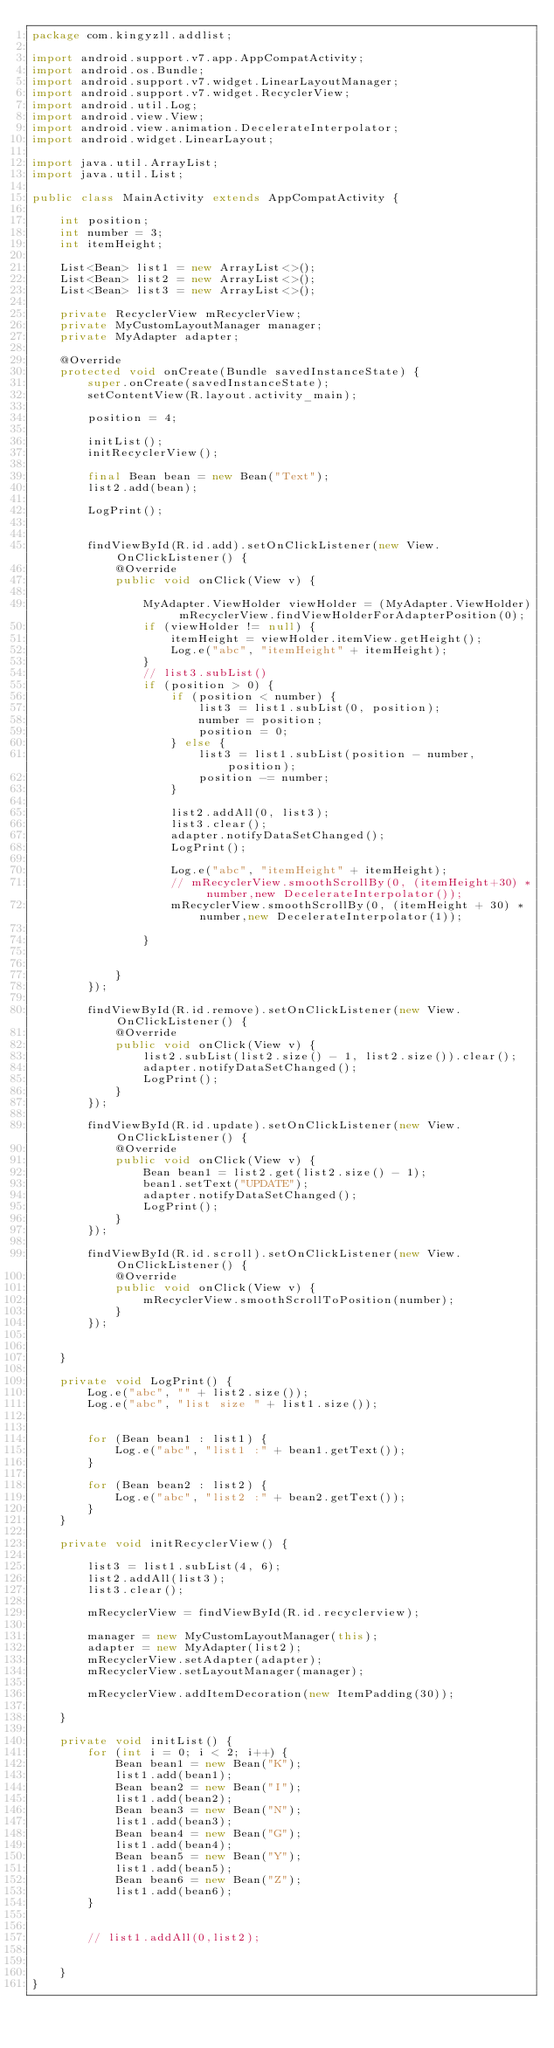<code> <loc_0><loc_0><loc_500><loc_500><_Java_>package com.kingyzll.addlist;

import android.support.v7.app.AppCompatActivity;
import android.os.Bundle;
import android.support.v7.widget.LinearLayoutManager;
import android.support.v7.widget.RecyclerView;
import android.util.Log;
import android.view.View;
import android.view.animation.DecelerateInterpolator;
import android.widget.LinearLayout;

import java.util.ArrayList;
import java.util.List;

public class MainActivity extends AppCompatActivity {

    int position;
    int number = 3;
    int itemHeight;

    List<Bean> list1 = new ArrayList<>();
    List<Bean> list2 = new ArrayList<>();
    List<Bean> list3 = new ArrayList<>();

    private RecyclerView mRecyclerView;
    private MyCustomLayoutManager manager;
    private MyAdapter adapter;

    @Override
    protected void onCreate(Bundle savedInstanceState) {
        super.onCreate(savedInstanceState);
        setContentView(R.layout.activity_main);

        position = 4;

        initList();
        initRecyclerView();

        final Bean bean = new Bean("Text");
        list2.add(bean);

        LogPrint();


        findViewById(R.id.add).setOnClickListener(new View.OnClickListener() {
            @Override
            public void onClick(View v) {

                MyAdapter.ViewHolder viewHolder = (MyAdapter.ViewHolder) mRecyclerView.findViewHolderForAdapterPosition(0);
                if (viewHolder != null) {
                    itemHeight = viewHolder.itemView.getHeight();
                    Log.e("abc", "itemHeight" + itemHeight);
                }
                // list3.subList()
                if (position > 0) {
                    if (position < number) {
                        list3 = list1.subList(0, position);
                        number = position;
                        position = 0;
                    } else {
                        list3 = list1.subList(position - number, position);
                        position -= number;
                    }

                    list2.addAll(0, list3);
                    list3.clear();
                    adapter.notifyDataSetChanged();
                    LogPrint();

                    Log.e("abc", "itemHeight" + itemHeight);
                    // mRecyclerView.smoothScrollBy(0, (itemHeight+30) * number,new DecelerateInterpolator());
                    mRecyclerView.smoothScrollBy(0, (itemHeight + 30) * number,new DecelerateInterpolator(1));

                }


            }
        });

        findViewById(R.id.remove).setOnClickListener(new View.OnClickListener() {
            @Override
            public void onClick(View v) {
                list2.subList(list2.size() - 1, list2.size()).clear();
                adapter.notifyDataSetChanged();
                LogPrint();
            }
        });

        findViewById(R.id.update).setOnClickListener(new View.OnClickListener() {
            @Override
            public void onClick(View v) {
                Bean bean1 = list2.get(list2.size() - 1);
                bean1.setText("UPDATE");
                adapter.notifyDataSetChanged();
                LogPrint();
            }
        });

        findViewById(R.id.scroll).setOnClickListener(new View.OnClickListener() {
            @Override
            public void onClick(View v) {
                mRecyclerView.smoothScrollToPosition(number);
            }
        });


    }

    private void LogPrint() {
        Log.e("abc", "" + list2.size());
        Log.e("abc", "list size " + list1.size());


        for (Bean bean1 : list1) {
            Log.e("abc", "list1 :" + bean1.getText());
        }

        for (Bean bean2 : list2) {
            Log.e("abc", "list2 :" + bean2.getText());
        }
    }

    private void initRecyclerView() {

        list3 = list1.subList(4, 6);
        list2.addAll(list3);
        list3.clear();

        mRecyclerView = findViewById(R.id.recyclerview);

        manager = new MyCustomLayoutManager(this);
        adapter = new MyAdapter(list2);
        mRecyclerView.setAdapter(adapter);
        mRecyclerView.setLayoutManager(manager);

        mRecyclerView.addItemDecoration(new ItemPadding(30));

    }

    private void initList() {
        for (int i = 0; i < 2; i++) {
            Bean bean1 = new Bean("K");
            list1.add(bean1);
            Bean bean2 = new Bean("I");
            list1.add(bean2);
            Bean bean3 = new Bean("N");
            list1.add(bean3);
            Bean bean4 = new Bean("G");
            list1.add(bean4);
            Bean bean5 = new Bean("Y");
            list1.add(bean5);
            Bean bean6 = new Bean("Z");
            list1.add(bean6);
        }


        // list1.addAll(0,list2);


    }
}
</code> 